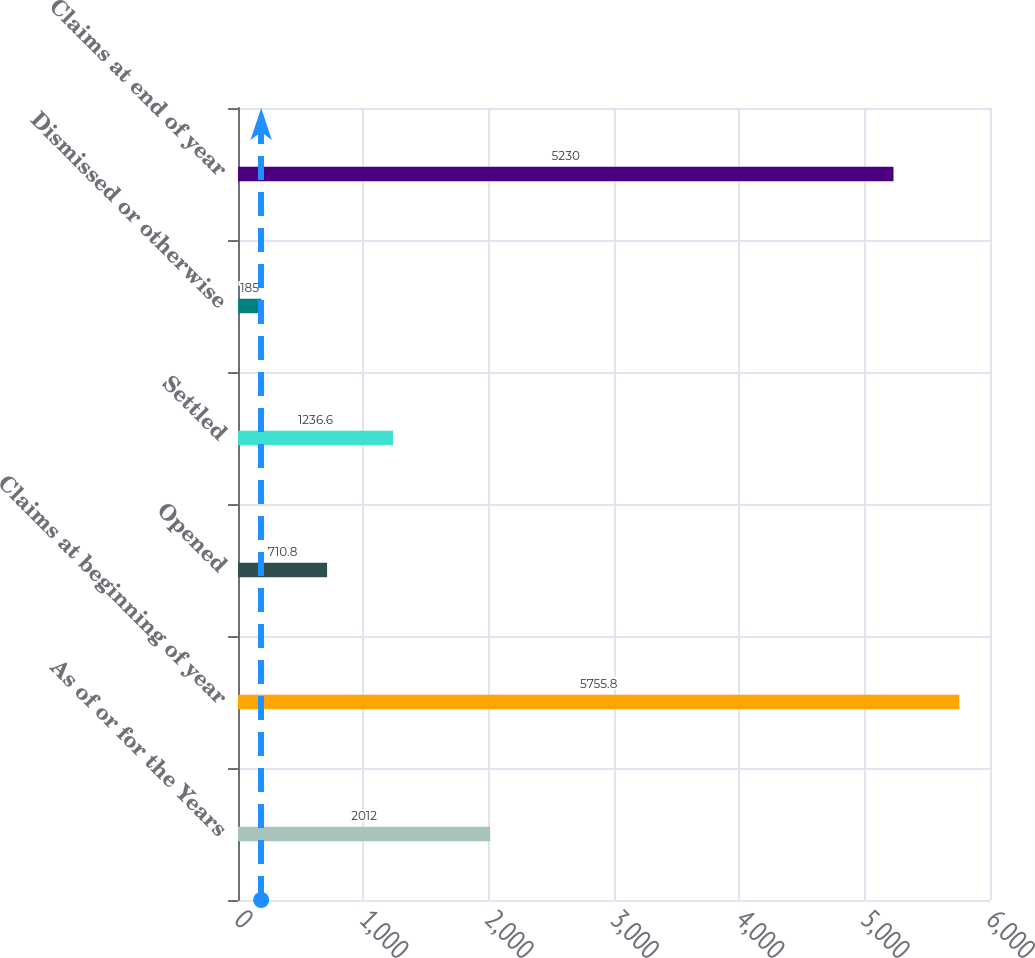<chart> <loc_0><loc_0><loc_500><loc_500><bar_chart><fcel>As of or for the Years<fcel>Claims at beginning of year<fcel>Opened<fcel>Settled<fcel>Dismissed or otherwise<fcel>Claims at end of year<nl><fcel>2012<fcel>5755.8<fcel>710.8<fcel>1236.6<fcel>185<fcel>5230<nl></chart> 